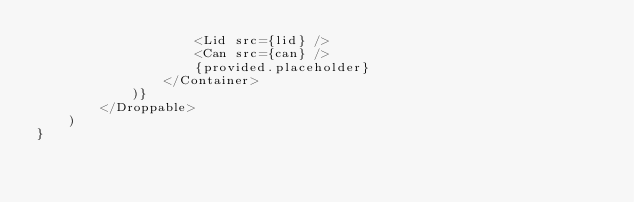<code> <loc_0><loc_0><loc_500><loc_500><_TypeScript_>                    <Lid src={lid} />
                    <Can src={can} />
                    {provided.placeholder}
                </Container>
            )}
        </Droppable>
    )
}</code> 